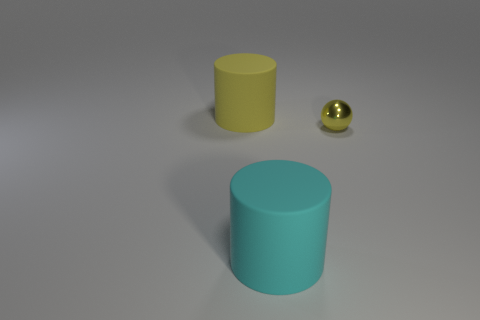Add 2 cyan cylinders. How many objects exist? 5 Subtract all cylinders. How many objects are left? 1 Subtract all big rubber cylinders. Subtract all tiny purple rubber blocks. How many objects are left? 1 Add 1 yellow cylinders. How many yellow cylinders are left? 2 Add 1 tiny yellow metal cylinders. How many tiny yellow metal cylinders exist? 1 Subtract 0 blue balls. How many objects are left? 3 